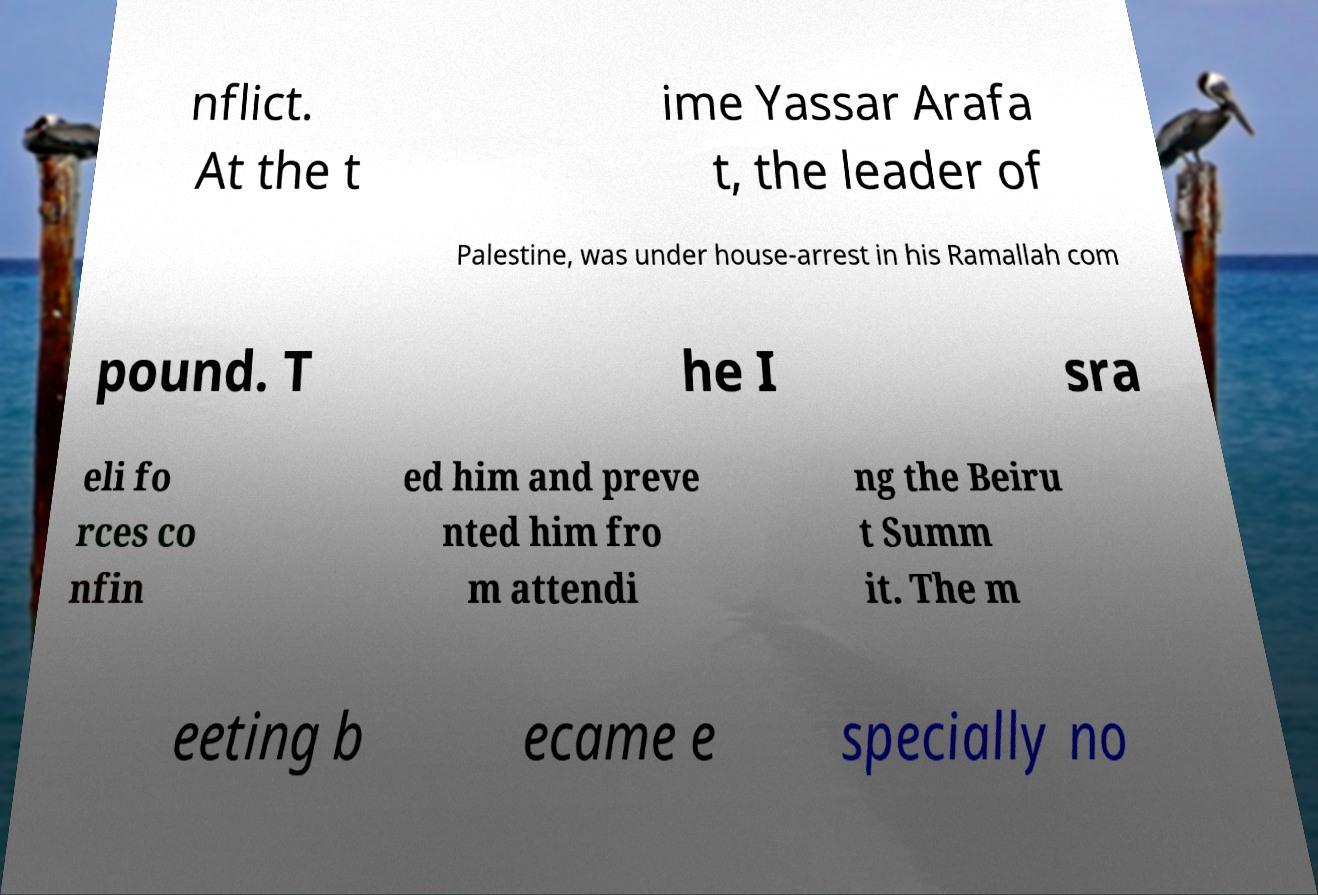Can you accurately transcribe the text from the provided image for me? nflict. At the t ime Yassar Arafa t, the leader of Palestine, was under house-arrest in his Ramallah com pound. T he I sra eli fo rces co nfin ed him and preve nted him fro m attendi ng the Beiru t Summ it. The m eeting b ecame e specially no 